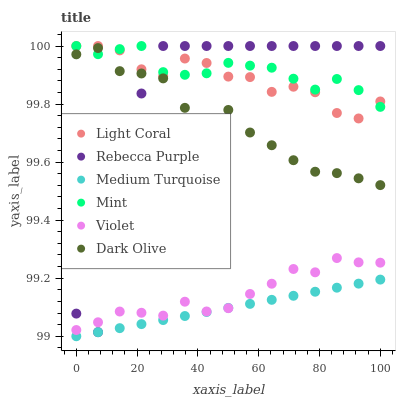Does Medium Turquoise have the minimum area under the curve?
Answer yes or no. Yes. Does Mint have the maximum area under the curve?
Answer yes or no. Yes. Does Light Coral have the minimum area under the curve?
Answer yes or no. No. Does Light Coral have the maximum area under the curve?
Answer yes or no. No. Is Medium Turquoise the smoothest?
Answer yes or no. Yes. Is Rebecca Purple the roughest?
Answer yes or no. Yes. Is Light Coral the smoothest?
Answer yes or no. No. Is Light Coral the roughest?
Answer yes or no. No. Does Medium Turquoise have the lowest value?
Answer yes or no. Yes. Does Light Coral have the lowest value?
Answer yes or no. No. Does Mint have the highest value?
Answer yes or no. Yes. Does Medium Turquoise have the highest value?
Answer yes or no. No. Is Violet less than Mint?
Answer yes or no. Yes. Is Dark Olive greater than Violet?
Answer yes or no. Yes. Does Violet intersect Medium Turquoise?
Answer yes or no. Yes. Is Violet less than Medium Turquoise?
Answer yes or no. No. Is Violet greater than Medium Turquoise?
Answer yes or no. No. Does Violet intersect Mint?
Answer yes or no. No. 